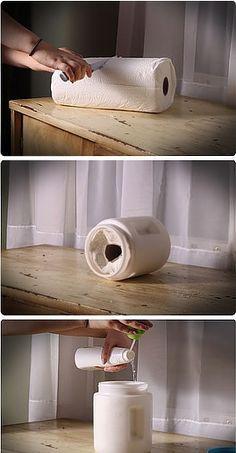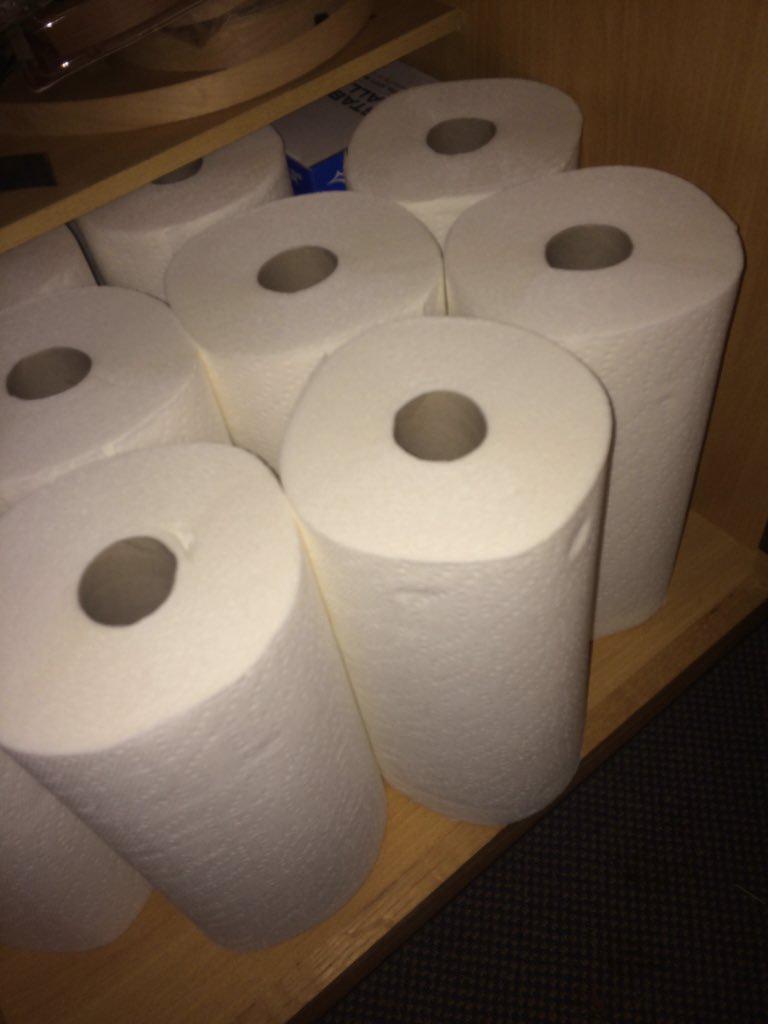The first image is the image on the left, the second image is the image on the right. Analyze the images presented: Is the assertion "In one image, a roll of white paper towels in on a chrome rack attached to the inside of a white cabinet door." valid? Answer yes or no. No. The first image is the image on the left, the second image is the image on the right. Examine the images to the left and right. Is the description "An image shows one white towel roll mounted on a bar hung on a cabinet door." accurate? Answer yes or no. No. 